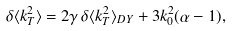Convert formula to latex. <formula><loc_0><loc_0><loc_500><loc_500>\delta \langle k _ { T } ^ { 2 } \rangle = 2 \gamma \, \delta \langle k _ { T } ^ { 2 } \rangle _ { D Y } + 3 k _ { 0 } ^ { 2 } ( \alpha - 1 ) ,</formula> 